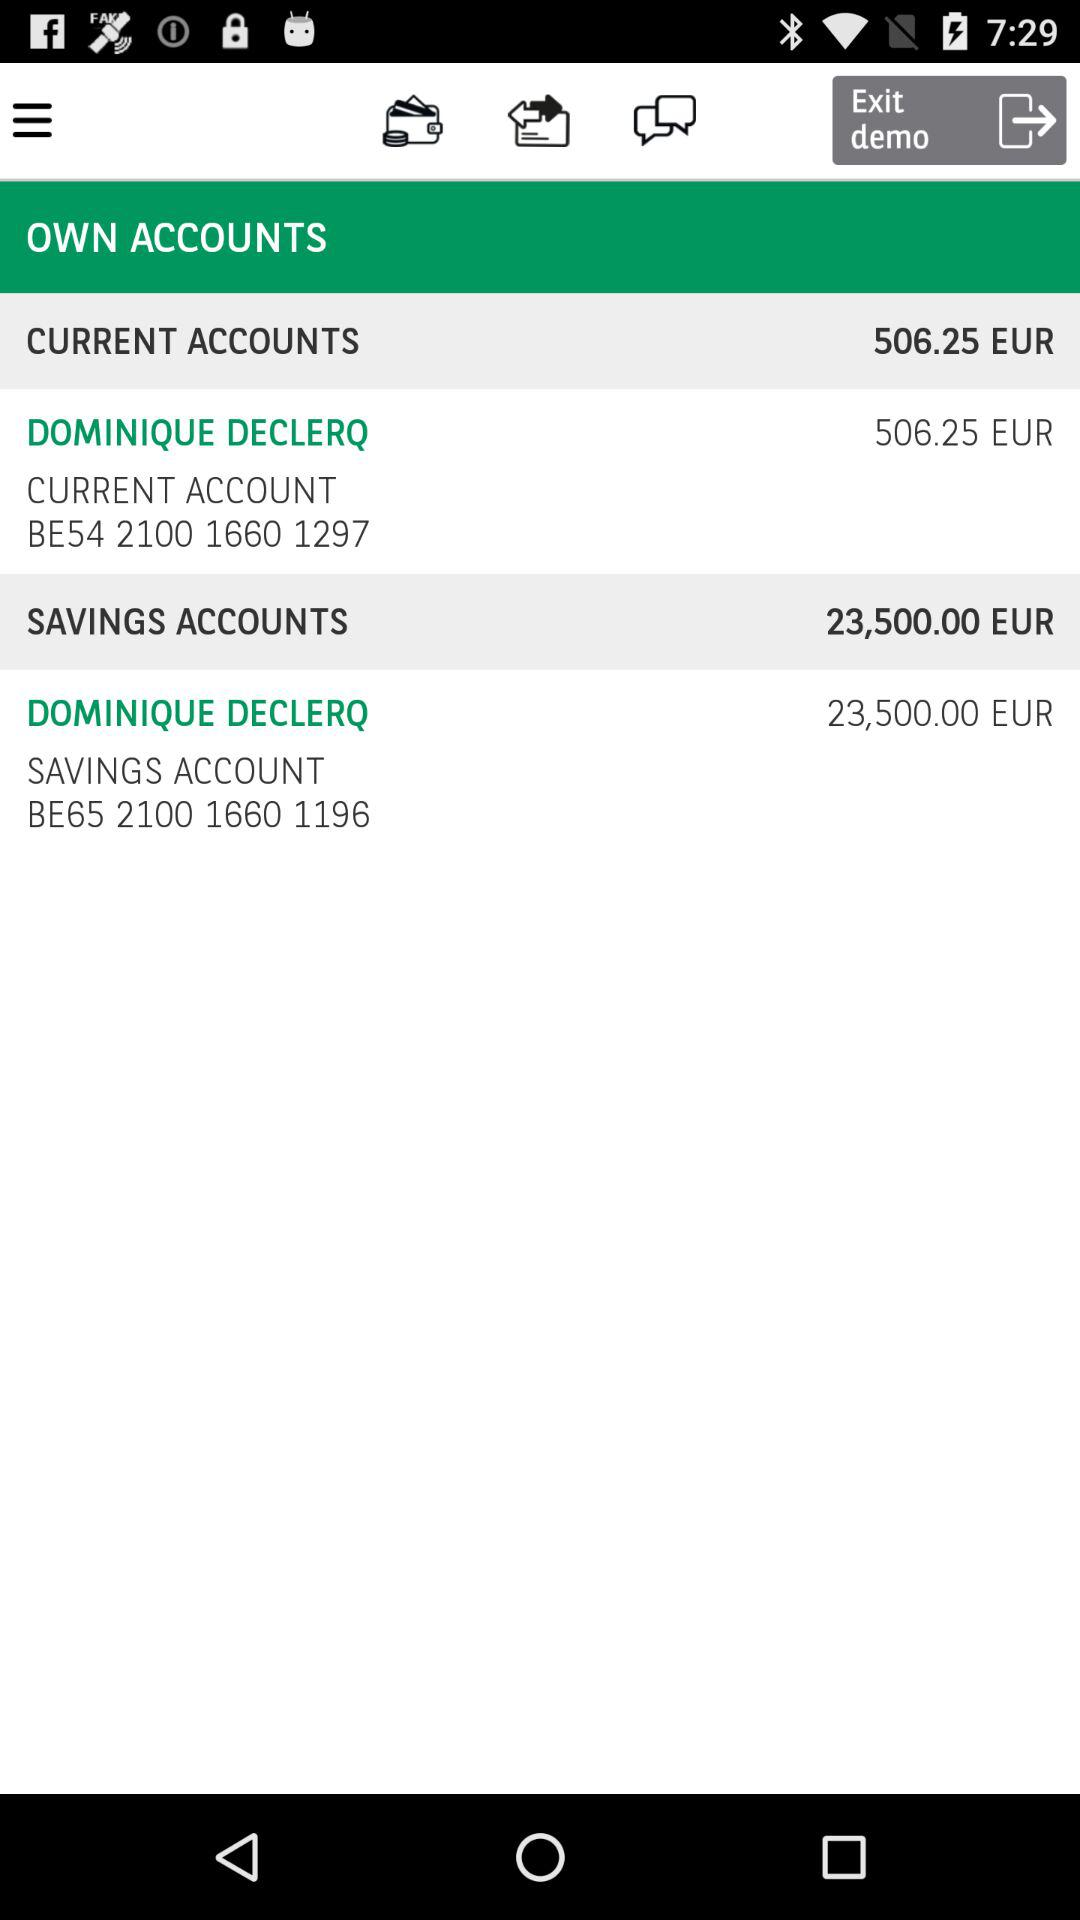How much money is in Dominique's savings account?
Answer the question using a single word or phrase. 23,500.00 EUR 